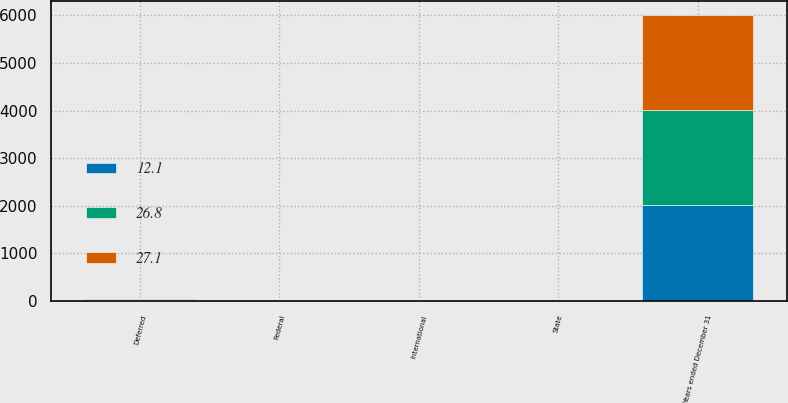Convert chart. <chart><loc_0><loc_0><loc_500><loc_500><stacked_bar_chart><ecel><fcel>Years ended December 31<fcel>Federal<fcel>State<fcel>International<fcel>Deferred<nl><fcel>12.1<fcel>2004<fcel>0.8<fcel>1.3<fcel>3.9<fcel>7.7<nl><fcel>27.1<fcel>2003<fcel>0.1<fcel>1.4<fcel>4.5<fcel>20.8<nl><fcel>26.8<fcel>2002<fcel>4.8<fcel>1.6<fcel>3.5<fcel>17.2<nl></chart> 